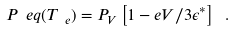Convert formula to latex. <formula><loc_0><loc_0><loc_500><loc_500>P _ { \ } e q ( T _ { \ e } ) = P _ { V } \left [ 1 - e V / 3 \epsilon ^ { * } \right ] \ .</formula> 